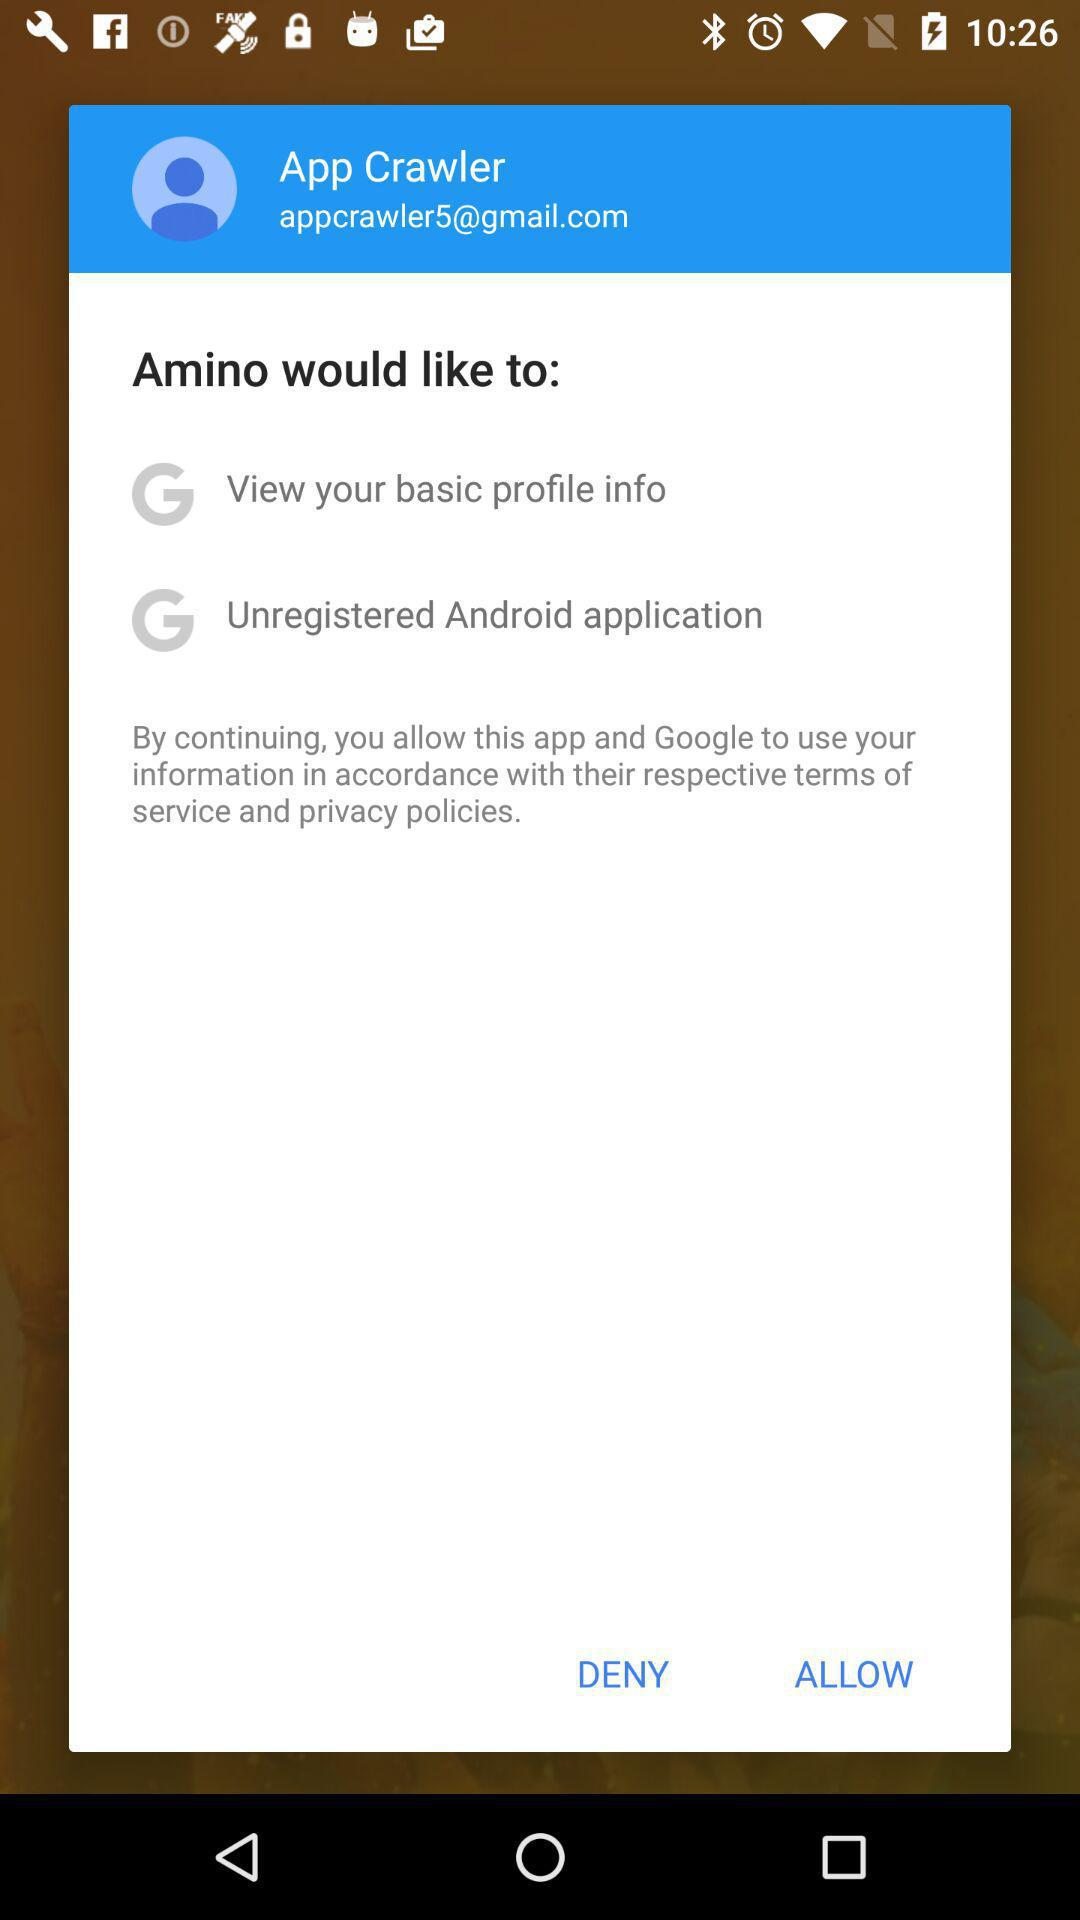What is the email address of the user? The email address of the user is appcrawler5@gmail.com. 